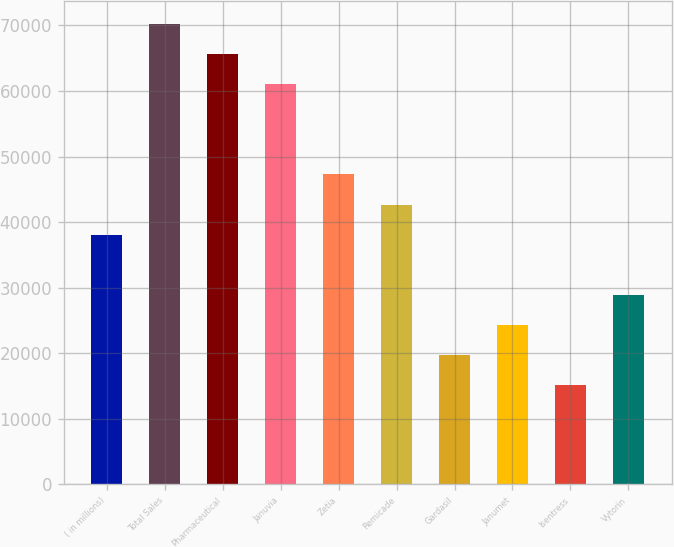<chart> <loc_0><loc_0><loc_500><loc_500><bar_chart><fcel>( in millions)<fcel>Total Sales<fcel>Pharmaceutical<fcel>Januvia<fcel>Zetia<fcel>Remicade<fcel>Gardasil<fcel>Janumet<fcel>Isentress<fcel>Vytorin<nl><fcel>38067.2<fcel>70266.5<fcel>65666.6<fcel>61066.7<fcel>47267<fcel>42667.1<fcel>19667.6<fcel>24267.5<fcel>15067.7<fcel>28867.4<nl></chart> 